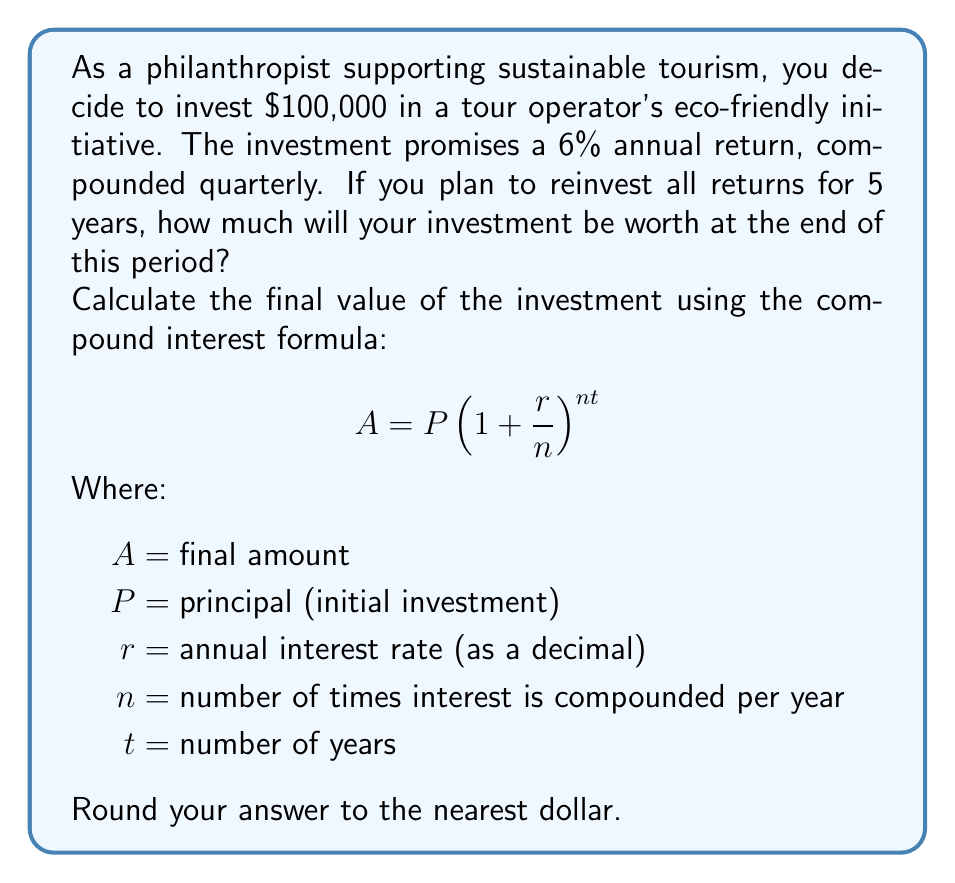Give your solution to this math problem. To solve this problem, we'll use the compound interest formula and plug in the given values:

$P = 100,000$ (initial investment)
$r = 0.06$ (6% annual return expressed as a decimal)
$n = 4$ (compounded quarterly, so 4 times per year)
$t = 5$ (5-year investment period)

Let's substitute these values into the formula:

$$A = 100,000(1 + \frac{0.06}{4})^{4 \times 5}$$

Now, let's solve step by step:

1) First, calculate $\frac{r}{n}$:
   $\frac{0.06}{4} = 0.015$

2) Add 1 to this value:
   $1 + 0.015 = 1.015$

3) Calculate the exponent $nt$:
   $4 \times 5 = 20$

4) Now our equation looks like this:
   $$A = 100,000(1.015)^{20}$$

5) Calculate $(1.015)^{20}$:
   $(1.015)^{20} \approx 1.3468539$

6) Multiply by the principal:
   $100,000 \times 1.3468539 = 134,685.39$

7) Round to the nearest dollar:
   $134,685

Therefore, after 5 years, the investment will be worth $134,685.
Answer: $134,685 